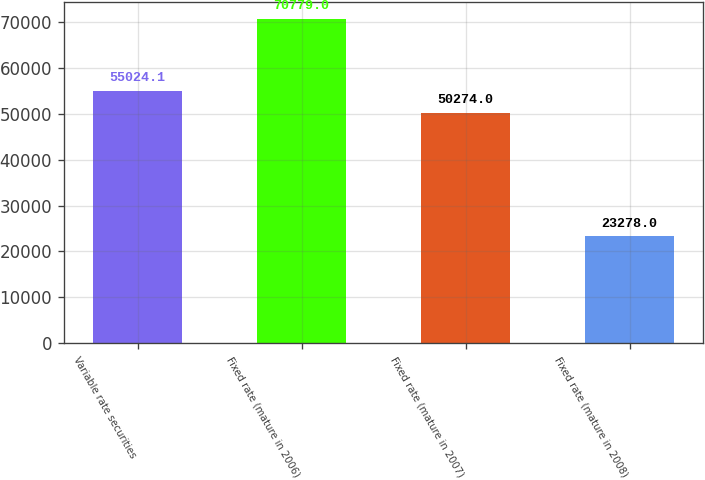Convert chart to OTSL. <chart><loc_0><loc_0><loc_500><loc_500><bar_chart><fcel>Variable rate securities<fcel>Fixed rate (mature in 2006)<fcel>Fixed rate (mature in 2007)<fcel>Fixed rate (mature in 2008)<nl><fcel>55024.1<fcel>70779<fcel>50274<fcel>23278<nl></chart> 